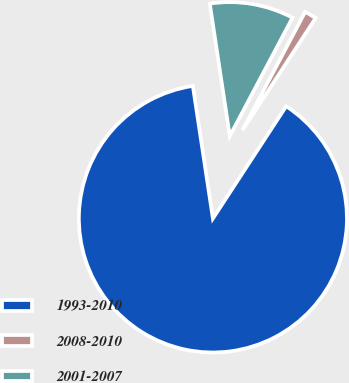Convert chart. <chart><loc_0><loc_0><loc_500><loc_500><pie_chart><fcel>1993-2010<fcel>2008-2010<fcel>2001-2007<nl><fcel>88.41%<fcel>1.45%<fcel>10.14%<nl></chart> 